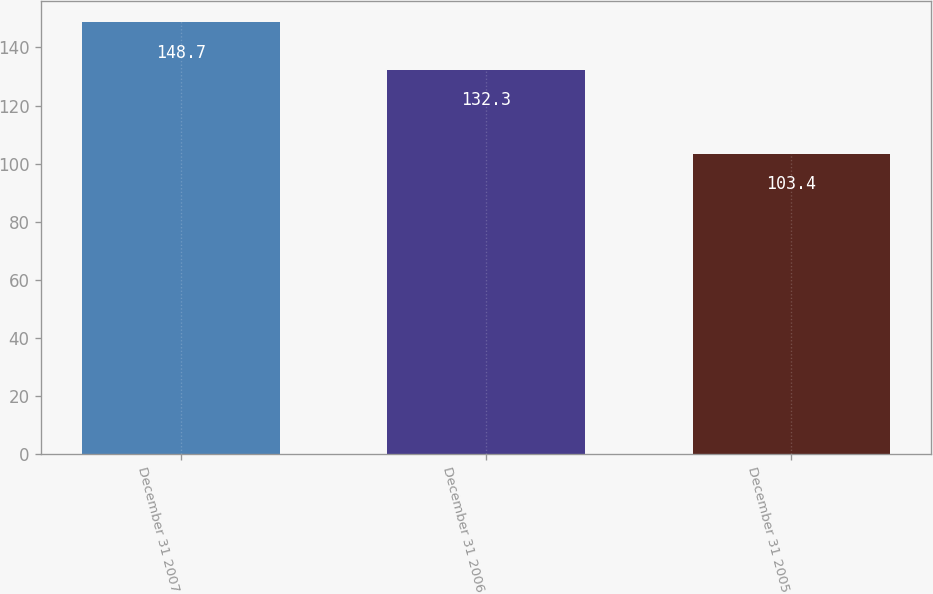Convert chart to OTSL. <chart><loc_0><loc_0><loc_500><loc_500><bar_chart><fcel>December 31 2007<fcel>December 31 2006<fcel>December 31 2005<nl><fcel>148.7<fcel>132.3<fcel>103.4<nl></chart> 